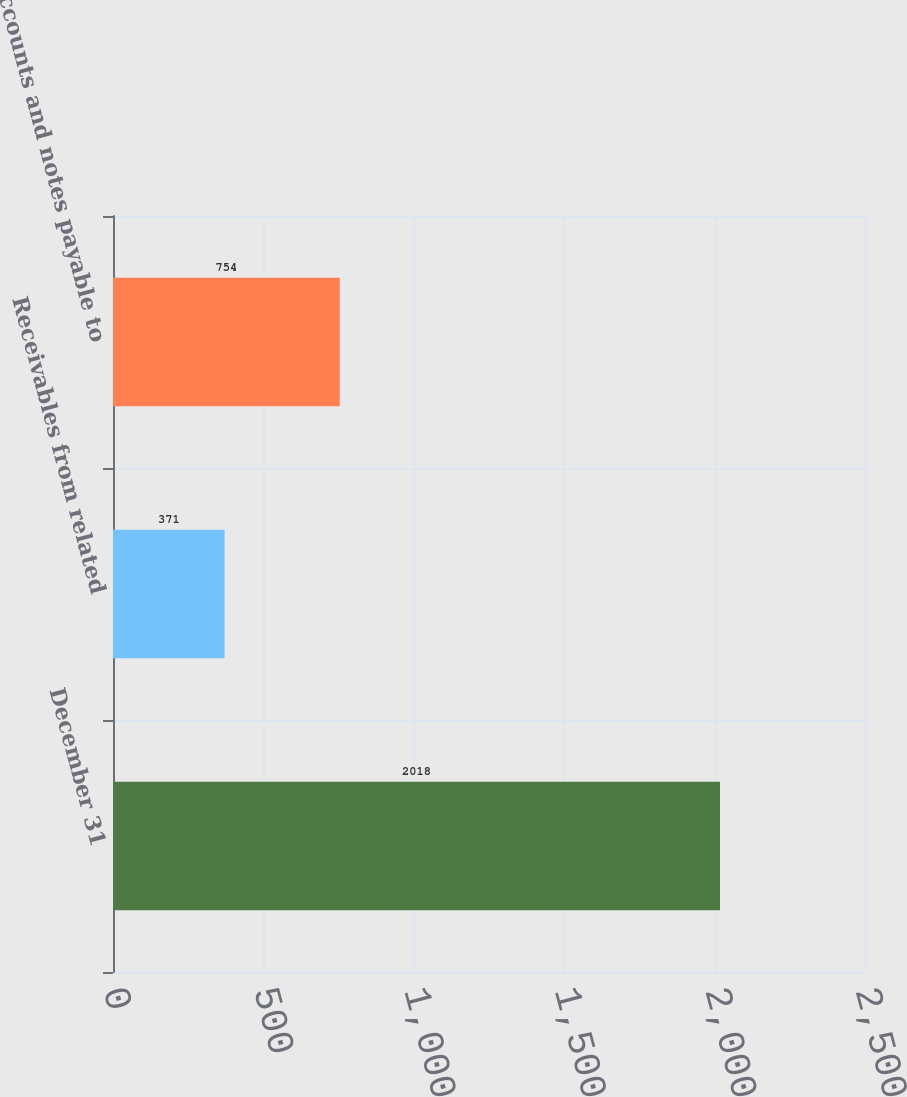Convert chart. <chart><loc_0><loc_0><loc_500><loc_500><bar_chart><fcel>December 31<fcel>Receivables from related<fcel>Accounts and notes payable to<nl><fcel>2018<fcel>371<fcel>754<nl></chart> 